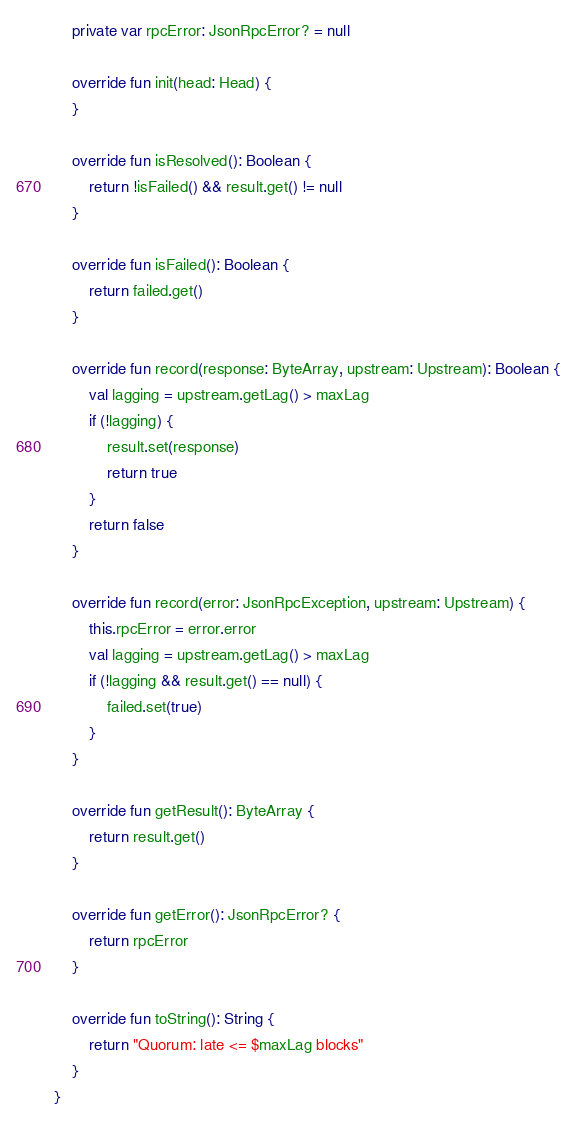Convert code to text. <code><loc_0><loc_0><loc_500><loc_500><_Kotlin_>    private var rpcError: JsonRpcError? = null

    override fun init(head: Head) {
    }

    override fun isResolved(): Boolean {
        return !isFailed() && result.get() != null
    }

    override fun isFailed(): Boolean {
        return failed.get()
    }

    override fun record(response: ByteArray, upstream: Upstream): Boolean {
        val lagging = upstream.getLag() > maxLag
        if (!lagging) {
            result.set(response)
            return true
        }
        return false
    }

    override fun record(error: JsonRpcException, upstream: Upstream) {
        this.rpcError = error.error
        val lagging = upstream.getLag() > maxLag
        if (!lagging && result.get() == null) {
            failed.set(true)
        }
    }

    override fun getResult(): ByteArray {
        return result.get()
    }

    override fun getError(): JsonRpcError? {
        return rpcError
    }

    override fun toString(): String {
        return "Quorum: late <= $maxLag blocks"
    }
}
</code> 